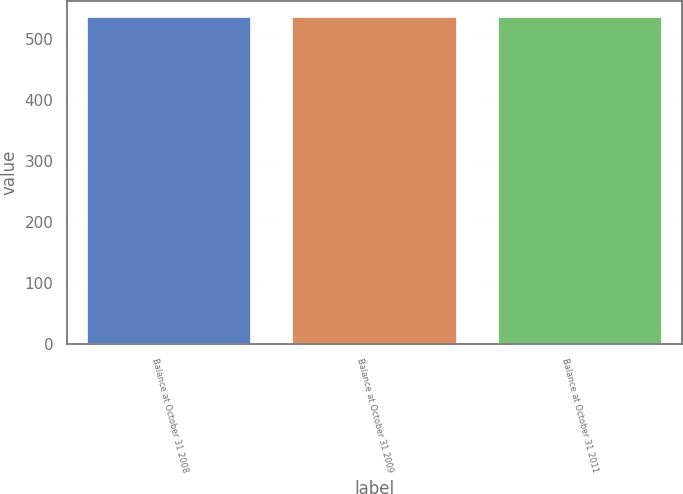Convert chart to OTSL. <chart><loc_0><loc_0><loc_500><loc_500><bar_chart><fcel>Balance at October 31 2008<fcel>Balance at October 31 2009<fcel>Balance at October 31 2011<nl><fcel>536.4<fcel>536.5<fcel>536.6<nl></chart> 